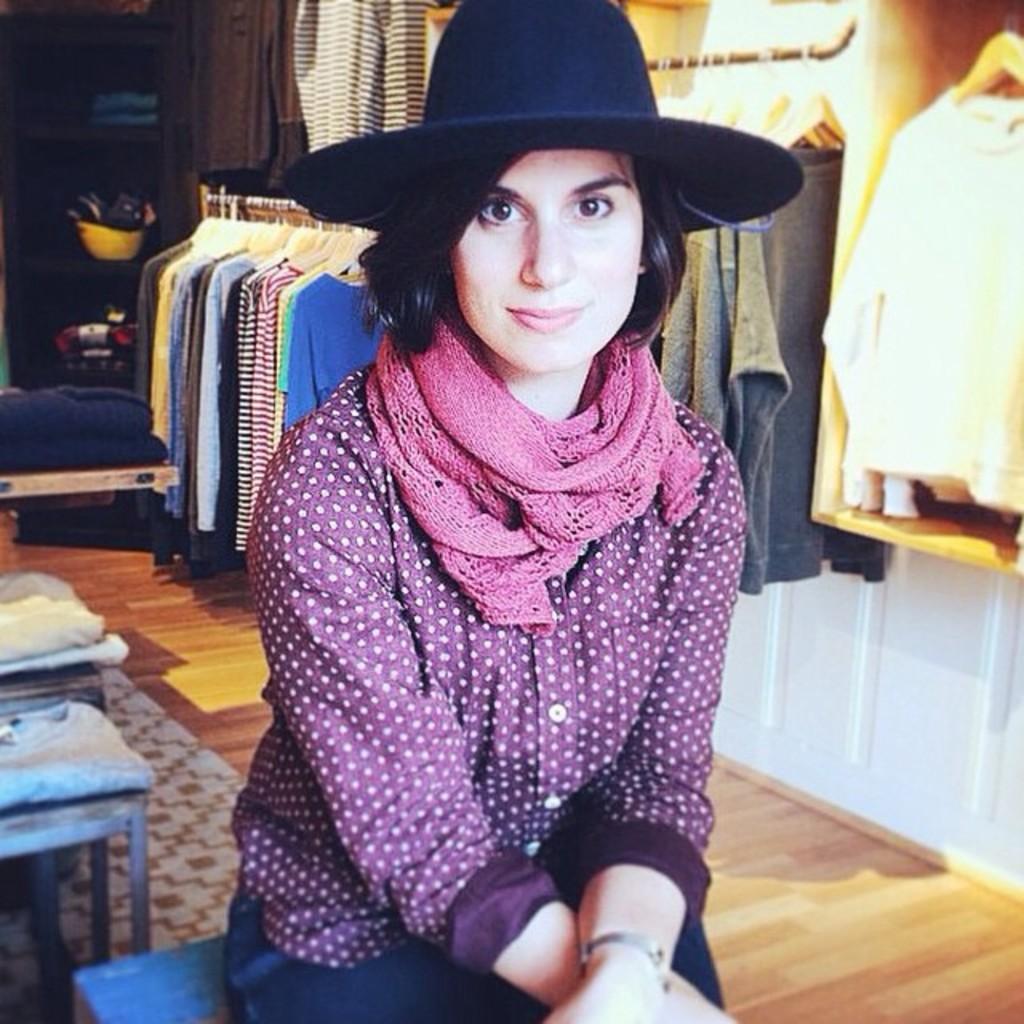Could you give a brief overview of what you see in this image? In this image I can see a person sitting and posing for a picture. This seems to be a cloth store I can see various clothes hanging. I can see some other objects behind. 